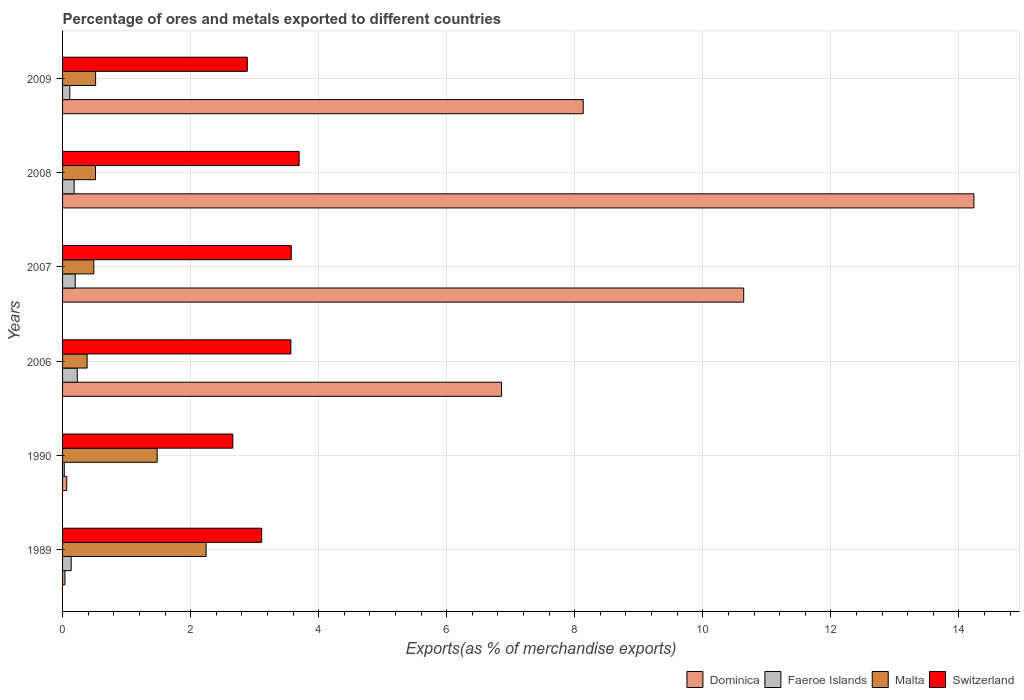Are the number of bars per tick equal to the number of legend labels?
Make the answer very short. Yes. What is the percentage of exports to different countries in Switzerland in 2007?
Give a very brief answer. 3.57. Across all years, what is the maximum percentage of exports to different countries in Dominica?
Provide a succinct answer. 14.24. Across all years, what is the minimum percentage of exports to different countries in Faeroe Islands?
Provide a succinct answer. 0.03. In which year was the percentage of exports to different countries in Dominica minimum?
Make the answer very short. 1989. What is the total percentage of exports to different countries in Malta in the graph?
Offer a terse response. 5.62. What is the difference between the percentage of exports to different countries in Dominica in 1989 and that in 1990?
Your answer should be compact. -0.03. What is the difference between the percentage of exports to different countries in Faeroe Islands in 2009 and the percentage of exports to different countries in Switzerland in 1989?
Your answer should be compact. -3. What is the average percentage of exports to different countries in Malta per year?
Ensure brevity in your answer.  0.94. In the year 1990, what is the difference between the percentage of exports to different countries in Faeroe Islands and percentage of exports to different countries in Malta?
Ensure brevity in your answer.  -1.45. What is the ratio of the percentage of exports to different countries in Switzerland in 1989 to that in 2008?
Your answer should be compact. 0.84. Is the difference between the percentage of exports to different countries in Faeroe Islands in 2007 and 2009 greater than the difference between the percentage of exports to different countries in Malta in 2007 and 2009?
Your answer should be very brief. Yes. What is the difference between the highest and the second highest percentage of exports to different countries in Faeroe Islands?
Your response must be concise. 0.03. What is the difference between the highest and the lowest percentage of exports to different countries in Dominica?
Ensure brevity in your answer.  14.2. What does the 4th bar from the top in 1989 represents?
Provide a short and direct response. Dominica. What does the 3rd bar from the bottom in 1989 represents?
Your response must be concise. Malta. Are all the bars in the graph horizontal?
Ensure brevity in your answer.  Yes. What is the difference between two consecutive major ticks on the X-axis?
Ensure brevity in your answer.  2. Does the graph contain any zero values?
Your response must be concise. No. Where does the legend appear in the graph?
Offer a terse response. Bottom right. How are the legend labels stacked?
Ensure brevity in your answer.  Horizontal. What is the title of the graph?
Your answer should be very brief. Percentage of ores and metals exported to different countries. What is the label or title of the X-axis?
Give a very brief answer. Exports(as % of merchandise exports). What is the Exports(as % of merchandise exports) of Dominica in 1989?
Offer a terse response. 0.04. What is the Exports(as % of merchandise exports) in Faeroe Islands in 1989?
Ensure brevity in your answer.  0.13. What is the Exports(as % of merchandise exports) in Malta in 1989?
Your response must be concise. 2.24. What is the Exports(as % of merchandise exports) in Switzerland in 1989?
Keep it short and to the point. 3.11. What is the Exports(as % of merchandise exports) in Dominica in 1990?
Your response must be concise. 0.07. What is the Exports(as % of merchandise exports) of Faeroe Islands in 1990?
Your answer should be compact. 0.03. What is the Exports(as % of merchandise exports) in Malta in 1990?
Provide a succinct answer. 1.48. What is the Exports(as % of merchandise exports) in Switzerland in 1990?
Your answer should be compact. 2.66. What is the Exports(as % of merchandise exports) in Dominica in 2006?
Keep it short and to the point. 6.86. What is the Exports(as % of merchandise exports) in Faeroe Islands in 2006?
Your answer should be very brief. 0.23. What is the Exports(as % of merchandise exports) of Malta in 2006?
Keep it short and to the point. 0.38. What is the Exports(as % of merchandise exports) in Switzerland in 2006?
Make the answer very short. 3.57. What is the Exports(as % of merchandise exports) of Dominica in 2007?
Your answer should be compact. 10.64. What is the Exports(as % of merchandise exports) in Faeroe Islands in 2007?
Offer a very short reply. 0.2. What is the Exports(as % of merchandise exports) of Malta in 2007?
Make the answer very short. 0.49. What is the Exports(as % of merchandise exports) in Switzerland in 2007?
Your answer should be compact. 3.57. What is the Exports(as % of merchandise exports) in Dominica in 2008?
Your answer should be compact. 14.24. What is the Exports(as % of merchandise exports) of Faeroe Islands in 2008?
Keep it short and to the point. 0.18. What is the Exports(as % of merchandise exports) of Malta in 2008?
Provide a succinct answer. 0.51. What is the Exports(as % of merchandise exports) of Switzerland in 2008?
Make the answer very short. 3.7. What is the Exports(as % of merchandise exports) of Dominica in 2009?
Provide a short and direct response. 8.13. What is the Exports(as % of merchandise exports) in Faeroe Islands in 2009?
Offer a terse response. 0.11. What is the Exports(as % of merchandise exports) of Malta in 2009?
Your answer should be compact. 0.52. What is the Exports(as % of merchandise exports) in Switzerland in 2009?
Make the answer very short. 2.89. Across all years, what is the maximum Exports(as % of merchandise exports) of Dominica?
Keep it short and to the point. 14.24. Across all years, what is the maximum Exports(as % of merchandise exports) in Faeroe Islands?
Provide a succinct answer. 0.23. Across all years, what is the maximum Exports(as % of merchandise exports) in Malta?
Offer a very short reply. 2.24. Across all years, what is the maximum Exports(as % of merchandise exports) in Switzerland?
Keep it short and to the point. 3.7. Across all years, what is the minimum Exports(as % of merchandise exports) of Dominica?
Make the answer very short. 0.04. Across all years, what is the minimum Exports(as % of merchandise exports) of Faeroe Islands?
Your response must be concise. 0.03. Across all years, what is the minimum Exports(as % of merchandise exports) in Malta?
Your answer should be compact. 0.38. Across all years, what is the minimum Exports(as % of merchandise exports) in Switzerland?
Offer a very short reply. 2.66. What is the total Exports(as % of merchandise exports) in Dominica in the graph?
Provide a succinct answer. 39.97. What is the total Exports(as % of merchandise exports) in Faeroe Islands in the graph?
Provide a succinct answer. 0.88. What is the total Exports(as % of merchandise exports) of Malta in the graph?
Your answer should be compact. 5.62. What is the total Exports(as % of merchandise exports) in Switzerland in the graph?
Offer a terse response. 19.49. What is the difference between the Exports(as % of merchandise exports) in Dominica in 1989 and that in 1990?
Offer a very short reply. -0.03. What is the difference between the Exports(as % of merchandise exports) of Faeroe Islands in 1989 and that in 1990?
Provide a succinct answer. 0.11. What is the difference between the Exports(as % of merchandise exports) in Malta in 1989 and that in 1990?
Give a very brief answer. 0.76. What is the difference between the Exports(as % of merchandise exports) in Switzerland in 1989 and that in 1990?
Offer a terse response. 0.45. What is the difference between the Exports(as % of merchandise exports) in Dominica in 1989 and that in 2006?
Ensure brevity in your answer.  -6.82. What is the difference between the Exports(as % of merchandise exports) in Faeroe Islands in 1989 and that in 2006?
Your answer should be compact. -0.1. What is the difference between the Exports(as % of merchandise exports) in Malta in 1989 and that in 2006?
Your response must be concise. 1.86. What is the difference between the Exports(as % of merchandise exports) of Switzerland in 1989 and that in 2006?
Your answer should be very brief. -0.46. What is the difference between the Exports(as % of merchandise exports) of Dominica in 1989 and that in 2007?
Keep it short and to the point. -10.6. What is the difference between the Exports(as % of merchandise exports) in Faeroe Islands in 1989 and that in 2007?
Give a very brief answer. -0.06. What is the difference between the Exports(as % of merchandise exports) in Malta in 1989 and that in 2007?
Offer a very short reply. 1.75. What is the difference between the Exports(as % of merchandise exports) of Switzerland in 1989 and that in 2007?
Your answer should be compact. -0.46. What is the difference between the Exports(as % of merchandise exports) of Dominica in 1989 and that in 2008?
Offer a very short reply. -14.2. What is the difference between the Exports(as % of merchandise exports) in Faeroe Islands in 1989 and that in 2008?
Provide a succinct answer. -0.05. What is the difference between the Exports(as % of merchandise exports) of Malta in 1989 and that in 2008?
Offer a very short reply. 1.73. What is the difference between the Exports(as % of merchandise exports) of Switzerland in 1989 and that in 2008?
Ensure brevity in your answer.  -0.58. What is the difference between the Exports(as % of merchandise exports) in Dominica in 1989 and that in 2009?
Make the answer very short. -8.09. What is the difference between the Exports(as % of merchandise exports) in Faeroe Islands in 1989 and that in 2009?
Provide a succinct answer. 0.02. What is the difference between the Exports(as % of merchandise exports) in Malta in 1989 and that in 2009?
Provide a short and direct response. 1.73. What is the difference between the Exports(as % of merchandise exports) of Switzerland in 1989 and that in 2009?
Your answer should be very brief. 0.22. What is the difference between the Exports(as % of merchandise exports) in Dominica in 1990 and that in 2006?
Ensure brevity in your answer.  -6.79. What is the difference between the Exports(as % of merchandise exports) of Faeroe Islands in 1990 and that in 2006?
Offer a very short reply. -0.2. What is the difference between the Exports(as % of merchandise exports) in Malta in 1990 and that in 2006?
Ensure brevity in your answer.  1.09. What is the difference between the Exports(as % of merchandise exports) in Switzerland in 1990 and that in 2006?
Your answer should be very brief. -0.91. What is the difference between the Exports(as % of merchandise exports) of Dominica in 1990 and that in 2007?
Your answer should be very brief. -10.57. What is the difference between the Exports(as % of merchandise exports) of Faeroe Islands in 1990 and that in 2007?
Keep it short and to the point. -0.17. What is the difference between the Exports(as % of merchandise exports) of Switzerland in 1990 and that in 2007?
Your answer should be compact. -0.91. What is the difference between the Exports(as % of merchandise exports) in Dominica in 1990 and that in 2008?
Your response must be concise. -14.17. What is the difference between the Exports(as % of merchandise exports) of Faeroe Islands in 1990 and that in 2008?
Your answer should be compact. -0.15. What is the difference between the Exports(as % of merchandise exports) in Malta in 1990 and that in 2008?
Offer a very short reply. 0.96. What is the difference between the Exports(as % of merchandise exports) of Switzerland in 1990 and that in 2008?
Provide a short and direct response. -1.04. What is the difference between the Exports(as % of merchandise exports) of Dominica in 1990 and that in 2009?
Provide a succinct answer. -8.07. What is the difference between the Exports(as % of merchandise exports) of Faeroe Islands in 1990 and that in 2009?
Provide a short and direct response. -0.09. What is the difference between the Exports(as % of merchandise exports) in Malta in 1990 and that in 2009?
Offer a very short reply. 0.96. What is the difference between the Exports(as % of merchandise exports) in Switzerland in 1990 and that in 2009?
Make the answer very short. -0.23. What is the difference between the Exports(as % of merchandise exports) of Dominica in 2006 and that in 2007?
Offer a terse response. -3.78. What is the difference between the Exports(as % of merchandise exports) of Faeroe Islands in 2006 and that in 2007?
Offer a terse response. 0.03. What is the difference between the Exports(as % of merchandise exports) in Malta in 2006 and that in 2007?
Keep it short and to the point. -0.11. What is the difference between the Exports(as % of merchandise exports) of Switzerland in 2006 and that in 2007?
Your response must be concise. -0.01. What is the difference between the Exports(as % of merchandise exports) in Dominica in 2006 and that in 2008?
Make the answer very short. -7.38. What is the difference between the Exports(as % of merchandise exports) in Faeroe Islands in 2006 and that in 2008?
Give a very brief answer. 0.05. What is the difference between the Exports(as % of merchandise exports) of Malta in 2006 and that in 2008?
Ensure brevity in your answer.  -0.13. What is the difference between the Exports(as % of merchandise exports) of Switzerland in 2006 and that in 2008?
Provide a short and direct response. -0.13. What is the difference between the Exports(as % of merchandise exports) of Dominica in 2006 and that in 2009?
Your answer should be very brief. -1.28. What is the difference between the Exports(as % of merchandise exports) of Faeroe Islands in 2006 and that in 2009?
Provide a short and direct response. 0.12. What is the difference between the Exports(as % of merchandise exports) of Malta in 2006 and that in 2009?
Offer a very short reply. -0.13. What is the difference between the Exports(as % of merchandise exports) in Switzerland in 2006 and that in 2009?
Provide a succinct answer. 0.68. What is the difference between the Exports(as % of merchandise exports) in Dominica in 2007 and that in 2008?
Your answer should be compact. -3.6. What is the difference between the Exports(as % of merchandise exports) of Faeroe Islands in 2007 and that in 2008?
Offer a terse response. 0.02. What is the difference between the Exports(as % of merchandise exports) of Malta in 2007 and that in 2008?
Provide a short and direct response. -0.03. What is the difference between the Exports(as % of merchandise exports) of Switzerland in 2007 and that in 2008?
Your answer should be compact. -0.12. What is the difference between the Exports(as % of merchandise exports) in Dominica in 2007 and that in 2009?
Your response must be concise. 2.51. What is the difference between the Exports(as % of merchandise exports) in Faeroe Islands in 2007 and that in 2009?
Keep it short and to the point. 0.09. What is the difference between the Exports(as % of merchandise exports) in Malta in 2007 and that in 2009?
Offer a very short reply. -0.03. What is the difference between the Exports(as % of merchandise exports) of Switzerland in 2007 and that in 2009?
Your answer should be compact. 0.69. What is the difference between the Exports(as % of merchandise exports) of Dominica in 2008 and that in 2009?
Provide a short and direct response. 6.1. What is the difference between the Exports(as % of merchandise exports) of Faeroe Islands in 2008 and that in 2009?
Offer a terse response. 0.07. What is the difference between the Exports(as % of merchandise exports) in Malta in 2008 and that in 2009?
Keep it short and to the point. -0. What is the difference between the Exports(as % of merchandise exports) in Switzerland in 2008 and that in 2009?
Provide a short and direct response. 0.81. What is the difference between the Exports(as % of merchandise exports) of Dominica in 1989 and the Exports(as % of merchandise exports) of Faeroe Islands in 1990?
Make the answer very short. 0.01. What is the difference between the Exports(as % of merchandise exports) of Dominica in 1989 and the Exports(as % of merchandise exports) of Malta in 1990?
Your response must be concise. -1.44. What is the difference between the Exports(as % of merchandise exports) in Dominica in 1989 and the Exports(as % of merchandise exports) in Switzerland in 1990?
Provide a succinct answer. -2.62. What is the difference between the Exports(as % of merchandise exports) in Faeroe Islands in 1989 and the Exports(as % of merchandise exports) in Malta in 1990?
Your answer should be very brief. -1.34. What is the difference between the Exports(as % of merchandise exports) of Faeroe Islands in 1989 and the Exports(as % of merchandise exports) of Switzerland in 1990?
Offer a very short reply. -2.52. What is the difference between the Exports(as % of merchandise exports) in Malta in 1989 and the Exports(as % of merchandise exports) in Switzerland in 1990?
Ensure brevity in your answer.  -0.42. What is the difference between the Exports(as % of merchandise exports) in Dominica in 1989 and the Exports(as % of merchandise exports) in Faeroe Islands in 2006?
Provide a succinct answer. -0.19. What is the difference between the Exports(as % of merchandise exports) in Dominica in 1989 and the Exports(as % of merchandise exports) in Malta in 2006?
Give a very brief answer. -0.35. What is the difference between the Exports(as % of merchandise exports) in Dominica in 1989 and the Exports(as % of merchandise exports) in Switzerland in 2006?
Make the answer very short. -3.53. What is the difference between the Exports(as % of merchandise exports) of Faeroe Islands in 1989 and the Exports(as % of merchandise exports) of Malta in 2006?
Ensure brevity in your answer.  -0.25. What is the difference between the Exports(as % of merchandise exports) in Faeroe Islands in 1989 and the Exports(as % of merchandise exports) in Switzerland in 2006?
Make the answer very short. -3.43. What is the difference between the Exports(as % of merchandise exports) in Malta in 1989 and the Exports(as % of merchandise exports) in Switzerland in 2006?
Your response must be concise. -1.32. What is the difference between the Exports(as % of merchandise exports) of Dominica in 1989 and the Exports(as % of merchandise exports) of Faeroe Islands in 2007?
Your response must be concise. -0.16. What is the difference between the Exports(as % of merchandise exports) in Dominica in 1989 and the Exports(as % of merchandise exports) in Malta in 2007?
Provide a succinct answer. -0.45. What is the difference between the Exports(as % of merchandise exports) in Dominica in 1989 and the Exports(as % of merchandise exports) in Switzerland in 2007?
Keep it short and to the point. -3.53. What is the difference between the Exports(as % of merchandise exports) in Faeroe Islands in 1989 and the Exports(as % of merchandise exports) in Malta in 2007?
Offer a very short reply. -0.35. What is the difference between the Exports(as % of merchandise exports) of Faeroe Islands in 1989 and the Exports(as % of merchandise exports) of Switzerland in 2007?
Provide a succinct answer. -3.44. What is the difference between the Exports(as % of merchandise exports) of Malta in 1989 and the Exports(as % of merchandise exports) of Switzerland in 2007?
Provide a succinct answer. -1.33. What is the difference between the Exports(as % of merchandise exports) in Dominica in 1989 and the Exports(as % of merchandise exports) in Faeroe Islands in 2008?
Offer a very short reply. -0.14. What is the difference between the Exports(as % of merchandise exports) of Dominica in 1989 and the Exports(as % of merchandise exports) of Malta in 2008?
Make the answer very short. -0.48. What is the difference between the Exports(as % of merchandise exports) in Dominica in 1989 and the Exports(as % of merchandise exports) in Switzerland in 2008?
Keep it short and to the point. -3.66. What is the difference between the Exports(as % of merchandise exports) of Faeroe Islands in 1989 and the Exports(as % of merchandise exports) of Malta in 2008?
Offer a very short reply. -0.38. What is the difference between the Exports(as % of merchandise exports) of Faeroe Islands in 1989 and the Exports(as % of merchandise exports) of Switzerland in 2008?
Keep it short and to the point. -3.56. What is the difference between the Exports(as % of merchandise exports) in Malta in 1989 and the Exports(as % of merchandise exports) in Switzerland in 2008?
Your answer should be very brief. -1.45. What is the difference between the Exports(as % of merchandise exports) in Dominica in 1989 and the Exports(as % of merchandise exports) in Faeroe Islands in 2009?
Keep it short and to the point. -0.08. What is the difference between the Exports(as % of merchandise exports) in Dominica in 1989 and the Exports(as % of merchandise exports) in Malta in 2009?
Keep it short and to the point. -0.48. What is the difference between the Exports(as % of merchandise exports) in Dominica in 1989 and the Exports(as % of merchandise exports) in Switzerland in 2009?
Your response must be concise. -2.85. What is the difference between the Exports(as % of merchandise exports) in Faeroe Islands in 1989 and the Exports(as % of merchandise exports) in Malta in 2009?
Your answer should be very brief. -0.38. What is the difference between the Exports(as % of merchandise exports) of Faeroe Islands in 1989 and the Exports(as % of merchandise exports) of Switzerland in 2009?
Your answer should be compact. -2.75. What is the difference between the Exports(as % of merchandise exports) of Malta in 1989 and the Exports(as % of merchandise exports) of Switzerland in 2009?
Offer a very short reply. -0.64. What is the difference between the Exports(as % of merchandise exports) of Dominica in 1990 and the Exports(as % of merchandise exports) of Faeroe Islands in 2006?
Make the answer very short. -0.16. What is the difference between the Exports(as % of merchandise exports) in Dominica in 1990 and the Exports(as % of merchandise exports) in Malta in 2006?
Provide a succinct answer. -0.32. What is the difference between the Exports(as % of merchandise exports) in Dominica in 1990 and the Exports(as % of merchandise exports) in Switzerland in 2006?
Your answer should be very brief. -3.5. What is the difference between the Exports(as % of merchandise exports) in Faeroe Islands in 1990 and the Exports(as % of merchandise exports) in Malta in 2006?
Ensure brevity in your answer.  -0.36. What is the difference between the Exports(as % of merchandise exports) in Faeroe Islands in 1990 and the Exports(as % of merchandise exports) in Switzerland in 2006?
Give a very brief answer. -3.54. What is the difference between the Exports(as % of merchandise exports) in Malta in 1990 and the Exports(as % of merchandise exports) in Switzerland in 2006?
Give a very brief answer. -2.09. What is the difference between the Exports(as % of merchandise exports) in Dominica in 1990 and the Exports(as % of merchandise exports) in Faeroe Islands in 2007?
Your answer should be compact. -0.13. What is the difference between the Exports(as % of merchandise exports) in Dominica in 1990 and the Exports(as % of merchandise exports) in Malta in 2007?
Your response must be concise. -0.42. What is the difference between the Exports(as % of merchandise exports) of Dominica in 1990 and the Exports(as % of merchandise exports) of Switzerland in 2007?
Provide a short and direct response. -3.51. What is the difference between the Exports(as % of merchandise exports) of Faeroe Islands in 1990 and the Exports(as % of merchandise exports) of Malta in 2007?
Provide a succinct answer. -0.46. What is the difference between the Exports(as % of merchandise exports) in Faeroe Islands in 1990 and the Exports(as % of merchandise exports) in Switzerland in 2007?
Offer a terse response. -3.55. What is the difference between the Exports(as % of merchandise exports) in Malta in 1990 and the Exports(as % of merchandise exports) in Switzerland in 2007?
Provide a succinct answer. -2.09. What is the difference between the Exports(as % of merchandise exports) in Dominica in 1990 and the Exports(as % of merchandise exports) in Faeroe Islands in 2008?
Your answer should be compact. -0.12. What is the difference between the Exports(as % of merchandise exports) in Dominica in 1990 and the Exports(as % of merchandise exports) in Malta in 2008?
Keep it short and to the point. -0.45. What is the difference between the Exports(as % of merchandise exports) in Dominica in 1990 and the Exports(as % of merchandise exports) in Switzerland in 2008?
Provide a short and direct response. -3.63. What is the difference between the Exports(as % of merchandise exports) of Faeroe Islands in 1990 and the Exports(as % of merchandise exports) of Malta in 2008?
Offer a terse response. -0.49. What is the difference between the Exports(as % of merchandise exports) in Faeroe Islands in 1990 and the Exports(as % of merchandise exports) in Switzerland in 2008?
Provide a short and direct response. -3.67. What is the difference between the Exports(as % of merchandise exports) of Malta in 1990 and the Exports(as % of merchandise exports) of Switzerland in 2008?
Offer a terse response. -2.22. What is the difference between the Exports(as % of merchandise exports) of Dominica in 1990 and the Exports(as % of merchandise exports) of Faeroe Islands in 2009?
Give a very brief answer. -0.05. What is the difference between the Exports(as % of merchandise exports) of Dominica in 1990 and the Exports(as % of merchandise exports) of Malta in 2009?
Your answer should be very brief. -0.45. What is the difference between the Exports(as % of merchandise exports) in Dominica in 1990 and the Exports(as % of merchandise exports) in Switzerland in 2009?
Keep it short and to the point. -2.82. What is the difference between the Exports(as % of merchandise exports) in Faeroe Islands in 1990 and the Exports(as % of merchandise exports) in Malta in 2009?
Offer a terse response. -0.49. What is the difference between the Exports(as % of merchandise exports) of Faeroe Islands in 1990 and the Exports(as % of merchandise exports) of Switzerland in 2009?
Your answer should be very brief. -2.86. What is the difference between the Exports(as % of merchandise exports) in Malta in 1990 and the Exports(as % of merchandise exports) in Switzerland in 2009?
Your answer should be compact. -1.41. What is the difference between the Exports(as % of merchandise exports) of Dominica in 2006 and the Exports(as % of merchandise exports) of Faeroe Islands in 2007?
Make the answer very short. 6.66. What is the difference between the Exports(as % of merchandise exports) of Dominica in 2006 and the Exports(as % of merchandise exports) of Malta in 2007?
Provide a succinct answer. 6.37. What is the difference between the Exports(as % of merchandise exports) of Dominica in 2006 and the Exports(as % of merchandise exports) of Switzerland in 2007?
Ensure brevity in your answer.  3.28. What is the difference between the Exports(as % of merchandise exports) in Faeroe Islands in 2006 and the Exports(as % of merchandise exports) in Malta in 2007?
Ensure brevity in your answer.  -0.26. What is the difference between the Exports(as % of merchandise exports) of Faeroe Islands in 2006 and the Exports(as % of merchandise exports) of Switzerland in 2007?
Offer a terse response. -3.34. What is the difference between the Exports(as % of merchandise exports) of Malta in 2006 and the Exports(as % of merchandise exports) of Switzerland in 2007?
Provide a succinct answer. -3.19. What is the difference between the Exports(as % of merchandise exports) of Dominica in 2006 and the Exports(as % of merchandise exports) of Faeroe Islands in 2008?
Your answer should be very brief. 6.68. What is the difference between the Exports(as % of merchandise exports) in Dominica in 2006 and the Exports(as % of merchandise exports) in Malta in 2008?
Give a very brief answer. 6.34. What is the difference between the Exports(as % of merchandise exports) of Dominica in 2006 and the Exports(as % of merchandise exports) of Switzerland in 2008?
Your response must be concise. 3.16. What is the difference between the Exports(as % of merchandise exports) of Faeroe Islands in 2006 and the Exports(as % of merchandise exports) of Malta in 2008?
Keep it short and to the point. -0.28. What is the difference between the Exports(as % of merchandise exports) of Faeroe Islands in 2006 and the Exports(as % of merchandise exports) of Switzerland in 2008?
Provide a succinct answer. -3.47. What is the difference between the Exports(as % of merchandise exports) in Malta in 2006 and the Exports(as % of merchandise exports) in Switzerland in 2008?
Provide a succinct answer. -3.31. What is the difference between the Exports(as % of merchandise exports) in Dominica in 2006 and the Exports(as % of merchandise exports) in Faeroe Islands in 2009?
Provide a short and direct response. 6.74. What is the difference between the Exports(as % of merchandise exports) in Dominica in 2006 and the Exports(as % of merchandise exports) in Malta in 2009?
Your answer should be compact. 6.34. What is the difference between the Exports(as % of merchandise exports) of Dominica in 2006 and the Exports(as % of merchandise exports) of Switzerland in 2009?
Offer a very short reply. 3.97. What is the difference between the Exports(as % of merchandise exports) of Faeroe Islands in 2006 and the Exports(as % of merchandise exports) of Malta in 2009?
Make the answer very short. -0.29. What is the difference between the Exports(as % of merchandise exports) in Faeroe Islands in 2006 and the Exports(as % of merchandise exports) in Switzerland in 2009?
Your response must be concise. -2.66. What is the difference between the Exports(as % of merchandise exports) of Malta in 2006 and the Exports(as % of merchandise exports) of Switzerland in 2009?
Keep it short and to the point. -2.5. What is the difference between the Exports(as % of merchandise exports) in Dominica in 2007 and the Exports(as % of merchandise exports) in Faeroe Islands in 2008?
Keep it short and to the point. 10.46. What is the difference between the Exports(as % of merchandise exports) of Dominica in 2007 and the Exports(as % of merchandise exports) of Malta in 2008?
Give a very brief answer. 10.12. What is the difference between the Exports(as % of merchandise exports) in Dominica in 2007 and the Exports(as % of merchandise exports) in Switzerland in 2008?
Ensure brevity in your answer.  6.94. What is the difference between the Exports(as % of merchandise exports) in Faeroe Islands in 2007 and the Exports(as % of merchandise exports) in Malta in 2008?
Your response must be concise. -0.32. What is the difference between the Exports(as % of merchandise exports) of Faeroe Islands in 2007 and the Exports(as % of merchandise exports) of Switzerland in 2008?
Give a very brief answer. -3.5. What is the difference between the Exports(as % of merchandise exports) in Malta in 2007 and the Exports(as % of merchandise exports) in Switzerland in 2008?
Your answer should be very brief. -3.21. What is the difference between the Exports(as % of merchandise exports) in Dominica in 2007 and the Exports(as % of merchandise exports) in Faeroe Islands in 2009?
Offer a terse response. 10.53. What is the difference between the Exports(as % of merchandise exports) in Dominica in 2007 and the Exports(as % of merchandise exports) in Malta in 2009?
Offer a terse response. 10.12. What is the difference between the Exports(as % of merchandise exports) of Dominica in 2007 and the Exports(as % of merchandise exports) of Switzerland in 2009?
Offer a very short reply. 7.75. What is the difference between the Exports(as % of merchandise exports) of Faeroe Islands in 2007 and the Exports(as % of merchandise exports) of Malta in 2009?
Your response must be concise. -0.32. What is the difference between the Exports(as % of merchandise exports) in Faeroe Islands in 2007 and the Exports(as % of merchandise exports) in Switzerland in 2009?
Your answer should be compact. -2.69. What is the difference between the Exports(as % of merchandise exports) in Malta in 2007 and the Exports(as % of merchandise exports) in Switzerland in 2009?
Offer a terse response. -2.4. What is the difference between the Exports(as % of merchandise exports) in Dominica in 2008 and the Exports(as % of merchandise exports) in Faeroe Islands in 2009?
Make the answer very short. 14.12. What is the difference between the Exports(as % of merchandise exports) in Dominica in 2008 and the Exports(as % of merchandise exports) in Malta in 2009?
Offer a very short reply. 13.72. What is the difference between the Exports(as % of merchandise exports) in Dominica in 2008 and the Exports(as % of merchandise exports) in Switzerland in 2009?
Offer a terse response. 11.35. What is the difference between the Exports(as % of merchandise exports) of Faeroe Islands in 2008 and the Exports(as % of merchandise exports) of Malta in 2009?
Offer a very short reply. -0.34. What is the difference between the Exports(as % of merchandise exports) in Faeroe Islands in 2008 and the Exports(as % of merchandise exports) in Switzerland in 2009?
Your response must be concise. -2.7. What is the difference between the Exports(as % of merchandise exports) of Malta in 2008 and the Exports(as % of merchandise exports) of Switzerland in 2009?
Your answer should be very brief. -2.37. What is the average Exports(as % of merchandise exports) of Dominica per year?
Give a very brief answer. 6.66. What is the average Exports(as % of merchandise exports) in Faeroe Islands per year?
Provide a short and direct response. 0.15. What is the average Exports(as % of merchandise exports) of Malta per year?
Keep it short and to the point. 0.94. What is the average Exports(as % of merchandise exports) in Switzerland per year?
Offer a very short reply. 3.25. In the year 1989, what is the difference between the Exports(as % of merchandise exports) of Dominica and Exports(as % of merchandise exports) of Faeroe Islands?
Give a very brief answer. -0.1. In the year 1989, what is the difference between the Exports(as % of merchandise exports) in Dominica and Exports(as % of merchandise exports) in Malta?
Your response must be concise. -2.2. In the year 1989, what is the difference between the Exports(as % of merchandise exports) in Dominica and Exports(as % of merchandise exports) in Switzerland?
Your response must be concise. -3.07. In the year 1989, what is the difference between the Exports(as % of merchandise exports) of Faeroe Islands and Exports(as % of merchandise exports) of Malta?
Offer a very short reply. -2.11. In the year 1989, what is the difference between the Exports(as % of merchandise exports) of Faeroe Islands and Exports(as % of merchandise exports) of Switzerland?
Ensure brevity in your answer.  -2.98. In the year 1989, what is the difference between the Exports(as % of merchandise exports) of Malta and Exports(as % of merchandise exports) of Switzerland?
Offer a terse response. -0.87. In the year 1990, what is the difference between the Exports(as % of merchandise exports) of Dominica and Exports(as % of merchandise exports) of Faeroe Islands?
Keep it short and to the point. 0.04. In the year 1990, what is the difference between the Exports(as % of merchandise exports) of Dominica and Exports(as % of merchandise exports) of Malta?
Offer a very short reply. -1.41. In the year 1990, what is the difference between the Exports(as % of merchandise exports) in Dominica and Exports(as % of merchandise exports) in Switzerland?
Your answer should be compact. -2.59. In the year 1990, what is the difference between the Exports(as % of merchandise exports) of Faeroe Islands and Exports(as % of merchandise exports) of Malta?
Your answer should be very brief. -1.45. In the year 1990, what is the difference between the Exports(as % of merchandise exports) of Faeroe Islands and Exports(as % of merchandise exports) of Switzerland?
Your response must be concise. -2.63. In the year 1990, what is the difference between the Exports(as % of merchandise exports) in Malta and Exports(as % of merchandise exports) in Switzerland?
Make the answer very short. -1.18. In the year 2006, what is the difference between the Exports(as % of merchandise exports) in Dominica and Exports(as % of merchandise exports) in Faeroe Islands?
Your answer should be very brief. 6.63. In the year 2006, what is the difference between the Exports(as % of merchandise exports) in Dominica and Exports(as % of merchandise exports) in Malta?
Your answer should be compact. 6.47. In the year 2006, what is the difference between the Exports(as % of merchandise exports) of Dominica and Exports(as % of merchandise exports) of Switzerland?
Give a very brief answer. 3.29. In the year 2006, what is the difference between the Exports(as % of merchandise exports) of Faeroe Islands and Exports(as % of merchandise exports) of Malta?
Your response must be concise. -0.15. In the year 2006, what is the difference between the Exports(as % of merchandise exports) of Faeroe Islands and Exports(as % of merchandise exports) of Switzerland?
Your response must be concise. -3.34. In the year 2006, what is the difference between the Exports(as % of merchandise exports) in Malta and Exports(as % of merchandise exports) in Switzerland?
Make the answer very short. -3.18. In the year 2007, what is the difference between the Exports(as % of merchandise exports) in Dominica and Exports(as % of merchandise exports) in Faeroe Islands?
Keep it short and to the point. 10.44. In the year 2007, what is the difference between the Exports(as % of merchandise exports) of Dominica and Exports(as % of merchandise exports) of Malta?
Offer a terse response. 10.15. In the year 2007, what is the difference between the Exports(as % of merchandise exports) in Dominica and Exports(as % of merchandise exports) in Switzerland?
Make the answer very short. 7.07. In the year 2007, what is the difference between the Exports(as % of merchandise exports) in Faeroe Islands and Exports(as % of merchandise exports) in Malta?
Offer a very short reply. -0.29. In the year 2007, what is the difference between the Exports(as % of merchandise exports) in Faeroe Islands and Exports(as % of merchandise exports) in Switzerland?
Provide a short and direct response. -3.37. In the year 2007, what is the difference between the Exports(as % of merchandise exports) in Malta and Exports(as % of merchandise exports) in Switzerland?
Give a very brief answer. -3.08. In the year 2008, what is the difference between the Exports(as % of merchandise exports) in Dominica and Exports(as % of merchandise exports) in Faeroe Islands?
Provide a succinct answer. 14.05. In the year 2008, what is the difference between the Exports(as % of merchandise exports) of Dominica and Exports(as % of merchandise exports) of Malta?
Ensure brevity in your answer.  13.72. In the year 2008, what is the difference between the Exports(as % of merchandise exports) of Dominica and Exports(as % of merchandise exports) of Switzerland?
Offer a terse response. 10.54. In the year 2008, what is the difference between the Exports(as % of merchandise exports) in Faeroe Islands and Exports(as % of merchandise exports) in Malta?
Provide a short and direct response. -0.33. In the year 2008, what is the difference between the Exports(as % of merchandise exports) of Faeroe Islands and Exports(as % of merchandise exports) of Switzerland?
Keep it short and to the point. -3.51. In the year 2008, what is the difference between the Exports(as % of merchandise exports) in Malta and Exports(as % of merchandise exports) in Switzerland?
Your answer should be compact. -3.18. In the year 2009, what is the difference between the Exports(as % of merchandise exports) of Dominica and Exports(as % of merchandise exports) of Faeroe Islands?
Keep it short and to the point. 8.02. In the year 2009, what is the difference between the Exports(as % of merchandise exports) in Dominica and Exports(as % of merchandise exports) in Malta?
Ensure brevity in your answer.  7.62. In the year 2009, what is the difference between the Exports(as % of merchandise exports) of Dominica and Exports(as % of merchandise exports) of Switzerland?
Provide a short and direct response. 5.25. In the year 2009, what is the difference between the Exports(as % of merchandise exports) of Faeroe Islands and Exports(as % of merchandise exports) of Malta?
Give a very brief answer. -0.4. In the year 2009, what is the difference between the Exports(as % of merchandise exports) of Faeroe Islands and Exports(as % of merchandise exports) of Switzerland?
Provide a succinct answer. -2.77. In the year 2009, what is the difference between the Exports(as % of merchandise exports) in Malta and Exports(as % of merchandise exports) in Switzerland?
Give a very brief answer. -2.37. What is the ratio of the Exports(as % of merchandise exports) of Dominica in 1989 to that in 1990?
Offer a terse response. 0.58. What is the ratio of the Exports(as % of merchandise exports) in Faeroe Islands in 1989 to that in 1990?
Your answer should be compact. 5.08. What is the ratio of the Exports(as % of merchandise exports) of Malta in 1989 to that in 1990?
Offer a very short reply. 1.52. What is the ratio of the Exports(as % of merchandise exports) in Switzerland in 1989 to that in 1990?
Make the answer very short. 1.17. What is the ratio of the Exports(as % of merchandise exports) of Dominica in 1989 to that in 2006?
Make the answer very short. 0.01. What is the ratio of the Exports(as % of merchandise exports) in Faeroe Islands in 1989 to that in 2006?
Your answer should be very brief. 0.59. What is the ratio of the Exports(as % of merchandise exports) of Malta in 1989 to that in 2006?
Give a very brief answer. 5.85. What is the ratio of the Exports(as % of merchandise exports) in Switzerland in 1989 to that in 2006?
Ensure brevity in your answer.  0.87. What is the ratio of the Exports(as % of merchandise exports) of Dominica in 1989 to that in 2007?
Provide a short and direct response. 0. What is the ratio of the Exports(as % of merchandise exports) of Faeroe Islands in 1989 to that in 2007?
Provide a succinct answer. 0.68. What is the ratio of the Exports(as % of merchandise exports) in Malta in 1989 to that in 2007?
Offer a terse response. 4.59. What is the ratio of the Exports(as % of merchandise exports) in Switzerland in 1989 to that in 2007?
Keep it short and to the point. 0.87. What is the ratio of the Exports(as % of merchandise exports) of Dominica in 1989 to that in 2008?
Give a very brief answer. 0. What is the ratio of the Exports(as % of merchandise exports) of Faeroe Islands in 1989 to that in 2008?
Ensure brevity in your answer.  0.74. What is the ratio of the Exports(as % of merchandise exports) of Malta in 1989 to that in 2008?
Offer a terse response. 4.36. What is the ratio of the Exports(as % of merchandise exports) of Switzerland in 1989 to that in 2008?
Make the answer very short. 0.84. What is the ratio of the Exports(as % of merchandise exports) in Dominica in 1989 to that in 2009?
Provide a short and direct response. 0. What is the ratio of the Exports(as % of merchandise exports) in Faeroe Islands in 1989 to that in 2009?
Your response must be concise. 1.19. What is the ratio of the Exports(as % of merchandise exports) in Malta in 1989 to that in 2009?
Provide a succinct answer. 4.34. What is the ratio of the Exports(as % of merchandise exports) of Switzerland in 1989 to that in 2009?
Your response must be concise. 1.08. What is the ratio of the Exports(as % of merchandise exports) of Dominica in 1990 to that in 2006?
Offer a terse response. 0.01. What is the ratio of the Exports(as % of merchandise exports) in Faeroe Islands in 1990 to that in 2006?
Ensure brevity in your answer.  0.12. What is the ratio of the Exports(as % of merchandise exports) of Malta in 1990 to that in 2006?
Keep it short and to the point. 3.86. What is the ratio of the Exports(as % of merchandise exports) in Switzerland in 1990 to that in 2006?
Your response must be concise. 0.75. What is the ratio of the Exports(as % of merchandise exports) in Dominica in 1990 to that in 2007?
Provide a short and direct response. 0.01. What is the ratio of the Exports(as % of merchandise exports) of Faeroe Islands in 1990 to that in 2007?
Provide a succinct answer. 0.13. What is the ratio of the Exports(as % of merchandise exports) of Malta in 1990 to that in 2007?
Offer a terse response. 3.02. What is the ratio of the Exports(as % of merchandise exports) in Switzerland in 1990 to that in 2007?
Keep it short and to the point. 0.74. What is the ratio of the Exports(as % of merchandise exports) in Dominica in 1990 to that in 2008?
Offer a very short reply. 0. What is the ratio of the Exports(as % of merchandise exports) in Faeroe Islands in 1990 to that in 2008?
Your answer should be very brief. 0.15. What is the ratio of the Exports(as % of merchandise exports) of Malta in 1990 to that in 2008?
Offer a terse response. 2.87. What is the ratio of the Exports(as % of merchandise exports) in Switzerland in 1990 to that in 2008?
Offer a very short reply. 0.72. What is the ratio of the Exports(as % of merchandise exports) in Dominica in 1990 to that in 2009?
Offer a very short reply. 0.01. What is the ratio of the Exports(as % of merchandise exports) in Faeroe Islands in 1990 to that in 2009?
Your answer should be compact. 0.23. What is the ratio of the Exports(as % of merchandise exports) in Malta in 1990 to that in 2009?
Provide a short and direct response. 2.86. What is the ratio of the Exports(as % of merchandise exports) in Switzerland in 1990 to that in 2009?
Offer a terse response. 0.92. What is the ratio of the Exports(as % of merchandise exports) in Dominica in 2006 to that in 2007?
Provide a short and direct response. 0.64. What is the ratio of the Exports(as % of merchandise exports) of Faeroe Islands in 2006 to that in 2007?
Ensure brevity in your answer.  1.16. What is the ratio of the Exports(as % of merchandise exports) in Malta in 2006 to that in 2007?
Your answer should be very brief. 0.78. What is the ratio of the Exports(as % of merchandise exports) in Switzerland in 2006 to that in 2007?
Offer a terse response. 1. What is the ratio of the Exports(as % of merchandise exports) of Dominica in 2006 to that in 2008?
Provide a succinct answer. 0.48. What is the ratio of the Exports(as % of merchandise exports) in Faeroe Islands in 2006 to that in 2008?
Provide a succinct answer. 1.27. What is the ratio of the Exports(as % of merchandise exports) of Malta in 2006 to that in 2008?
Give a very brief answer. 0.75. What is the ratio of the Exports(as % of merchandise exports) in Dominica in 2006 to that in 2009?
Keep it short and to the point. 0.84. What is the ratio of the Exports(as % of merchandise exports) in Faeroe Islands in 2006 to that in 2009?
Ensure brevity in your answer.  2.03. What is the ratio of the Exports(as % of merchandise exports) of Malta in 2006 to that in 2009?
Ensure brevity in your answer.  0.74. What is the ratio of the Exports(as % of merchandise exports) of Switzerland in 2006 to that in 2009?
Your answer should be very brief. 1.24. What is the ratio of the Exports(as % of merchandise exports) of Dominica in 2007 to that in 2008?
Provide a short and direct response. 0.75. What is the ratio of the Exports(as % of merchandise exports) of Faeroe Islands in 2007 to that in 2008?
Your answer should be compact. 1.1. What is the ratio of the Exports(as % of merchandise exports) in Switzerland in 2007 to that in 2008?
Give a very brief answer. 0.97. What is the ratio of the Exports(as % of merchandise exports) of Dominica in 2007 to that in 2009?
Your answer should be very brief. 1.31. What is the ratio of the Exports(as % of merchandise exports) in Faeroe Islands in 2007 to that in 2009?
Your answer should be very brief. 1.76. What is the ratio of the Exports(as % of merchandise exports) of Malta in 2007 to that in 2009?
Offer a very short reply. 0.95. What is the ratio of the Exports(as % of merchandise exports) of Switzerland in 2007 to that in 2009?
Your answer should be compact. 1.24. What is the ratio of the Exports(as % of merchandise exports) in Dominica in 2008 to that in 2009?
Your answer should be very brief. 1.75. What is the ratio of the Exports(as % of merchandise exports) of Faeroe Islands in 2008 to that in 2009?
Your answer should be compact. 1.6. What is the ratio of the Exports(as % of merchandise exports) in Malta in 2008 to that in 2009?
Give a very brief answer. 1. What is the ratio of the Exports(as % of merchandise exports) of Switzerland in 2008 to that in 2009?
Keep it short and to the point. 1.28. What is the difference between the highest and the second highest Exports(as % of merchandise exports) in Dominica?
Provide a succinct answer. 3.6. What is the difference between the highest and the second highest Exports(as % of merchandise exports) of Faeroe Islands?
Give a very brief answer. 0.03. What is the difference between the highest and the second highest Exports(as % of merchandise exports) in Malta?
Provide a short and direct response. 0.76. What is the difference between the highest and the second highest Exports(as % of merchandise exports) in Switzerland?
Provide a succinct answer. 0.12. What is the difference between the highest and the lowest Exports(as % of merchandise exports) of Dominica?
Your response must be concise. 14.2. What is the difference between the highest and the lowest Exports(as % of merchandise exports) of Faeroe Islands?
Make the answer very short. 0.2. What is the difference between the highest and the lowest Exports(as % of merchandise exports) in Malta?
Your answer should be compact. 1.86. What is the difference between the highest and the lowest Exports(as % of merchandise exports) of Switzerland?
Ensure brevity in your answer.  1.04. 